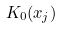<formula> <loc_0><loc_0><loc_500><loc_500>K _ { 0 } ( x _ { j } )</formula> 